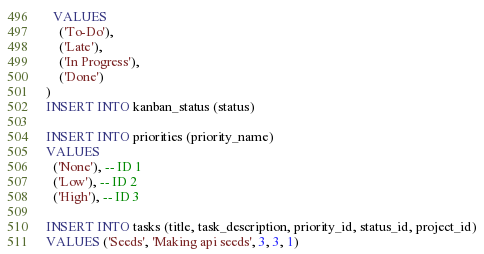Convert code to text. <code><loc_0><loc_0><loc_500><loc_500><_SQL_>  VALUES
    ('To-Do'),
    ('Late'),
    ('In Progress'),
    ('Done')
)
INSERT INTO kanban_status (status)

INSERT INTO priorities (priority_name)
VALUES 
  ('None'), -- ID 1
  ('Low'), -- ID 2
  ('High'), -- ID 3

INSERT INTO tasks (title, task_description, priority_id, status_id, project_id)
VALUES ('Seeds', 'Making api seeds', 3, 3, 1)</code> 